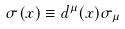Convert formula to latex. <formula><loc_0><loc_0><loc_500><loc_500>\sigma ( { x } ) \equiv d ^ { \mu } ( { x } ) \sigma _ { \mu }</formula> 